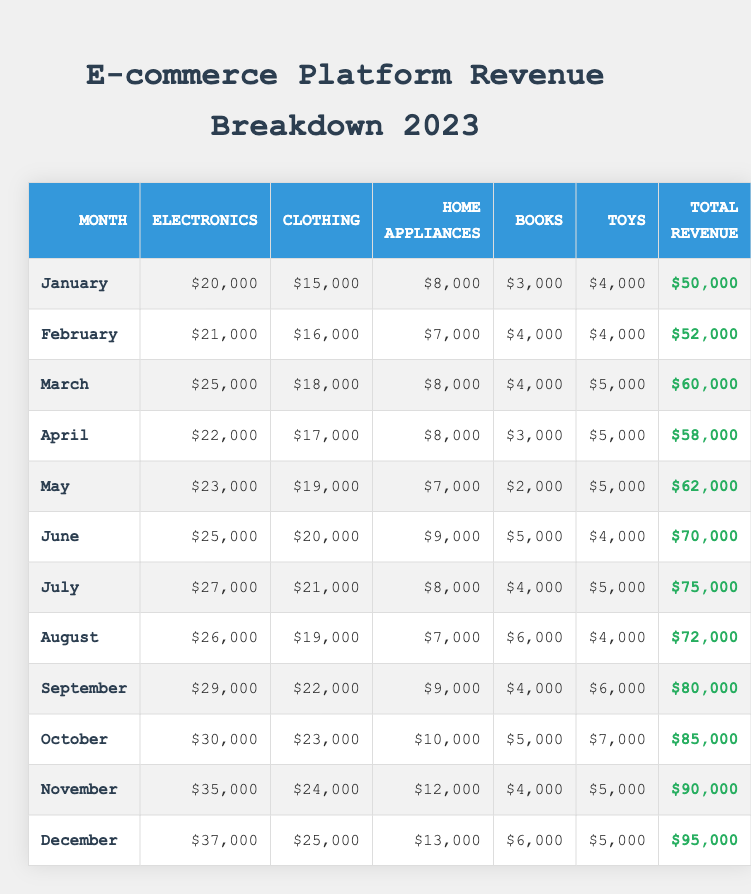What was the total revenue for November? The total revenue for November is explicitly listed in the table under the "Total Revenue" column for that month, which shows $90,000.
Answer: $90,000 Which month had the highest revenue from electronics? By examining the "Electronics" column, October has the highest amount at $30,000.
Answer: October What is the difference in clothing revenue between March and April? March has a clothing revenue of $18,000, while April has $17,000. The difference is calculated as $18,000 - $17,000 = $1,000.
Answer: $1,000 Which month had a total revenue of $70,000? The total revenue of $70,000 appears under June in the "Total Revenue" column.
Answer: June What is the average monthly revenue for the first quarter (January to March)? The total revenue for January ($50,000), February ($52,000), and March ($60,000) is summed to get $162,000. There are three months, so the average revenue is $162,000 / 3 = $54,000.
Answer: $54,000 Is the revenue from toys higher in August than in January? August has toy revenue of $4,000 and January has $4,000. Since both values are equal, it is false that August is higher.
Answer: No What percentage of the total revenue in December comes from electronics? December's total revenue is $95,000, with electronics revenue of $37,000. The percentage is calculated as ($37,000 / $95,000) × 100 = 38.95%, rounded to approximately 39%.
Answer: 39% What was the total revenue from home appliances in the second half of the year (July to December)? Home appliances revenue from July ($8,000) + August ($7,000) + September ($9,000) + October ($10,000) + November ($12,000) + December ($13,000) totals to $69,000.
Answer: $69,000 During which month was the clothing revenue at least $20,000? Looking at the "Clothing" column, the only month with revenue at least $20,000 is July, which shows $21,000.
Answer: July How did the total monthly revenue trend from January to December? Analyzing the "Total Revenue" column, the values increase each month, starting from $50,000 in January to $95,000 in December, indicating a consistent upward trend.
Answer: Increasing What is the total revenue increase from May to June? May's total revenue is $62,000, while June's is $70,000. The increase can be calculated as $70,000 - $62,000 = $8,000.
Answer: $8,000 